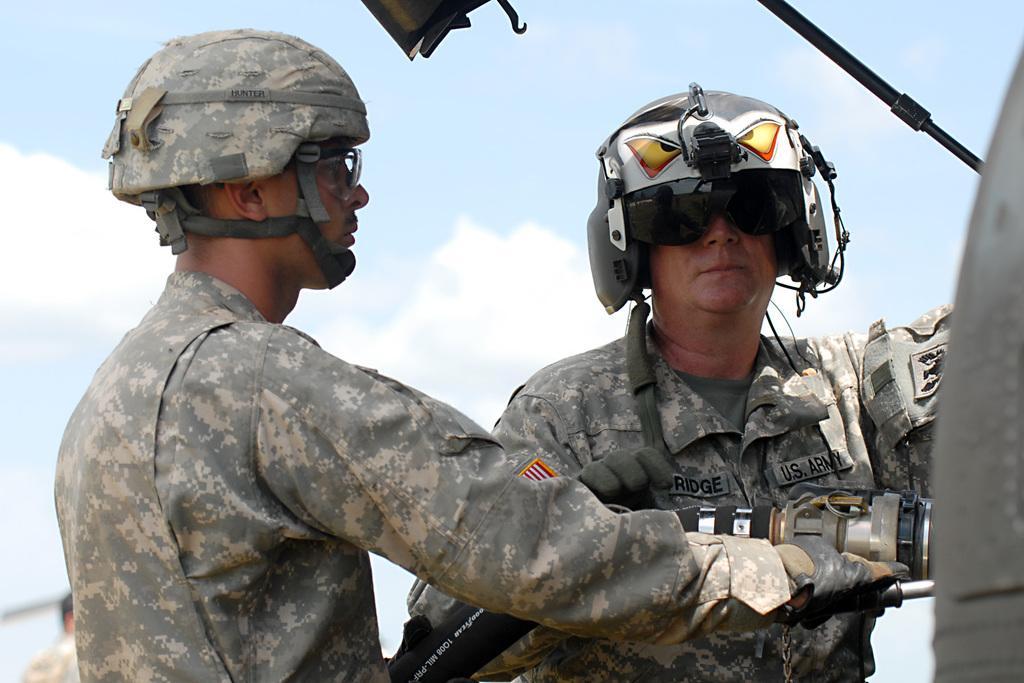In one or two sentences, can you explain what this image depicts? This picture describes about group of people, few people wore helmets, on the left side of the image we can see a man, he is holding a pipe. 